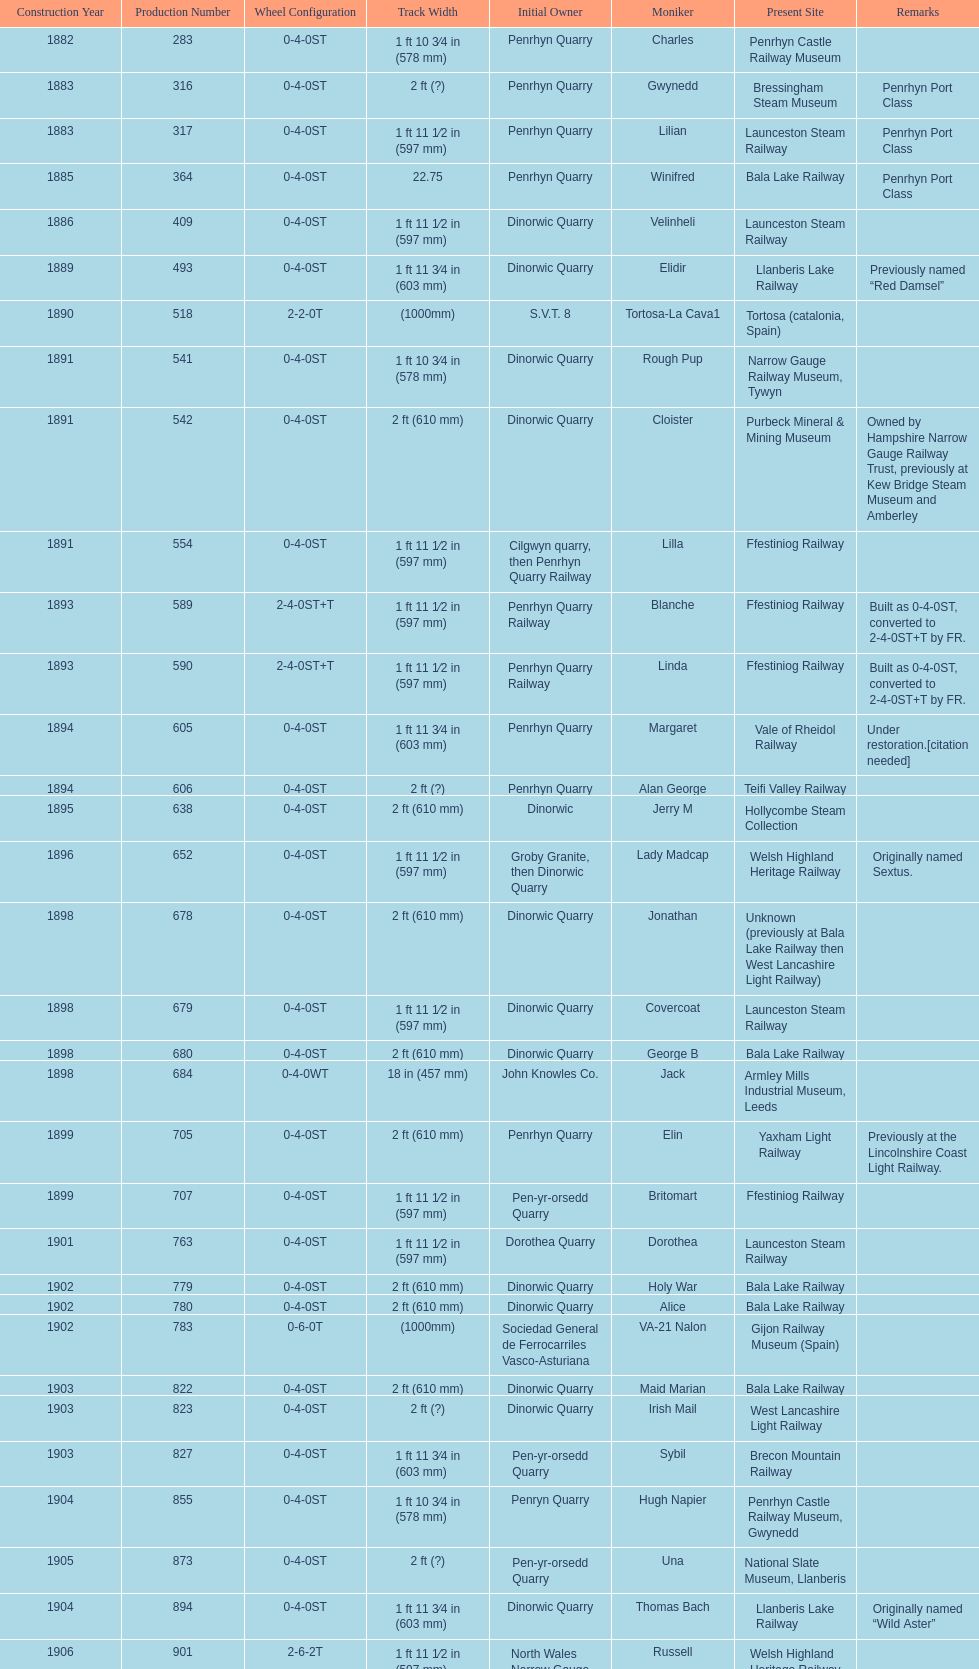Who owned the last locomotive to be built? Trangkil Sugar Mill, Indonesia. 